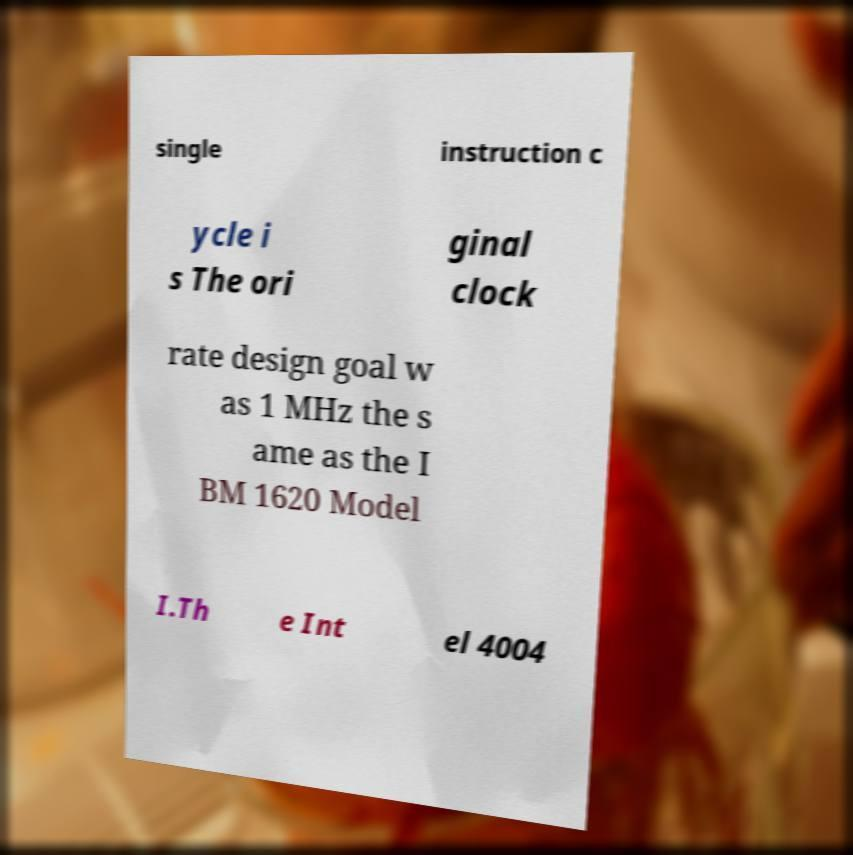Could you extract and type out the text from this image? single instruction c ycle i s The ori ginal clock rate design goal w as 1 MHz the s ame as the I BM 1620 Model I.Th e Int el 4004 